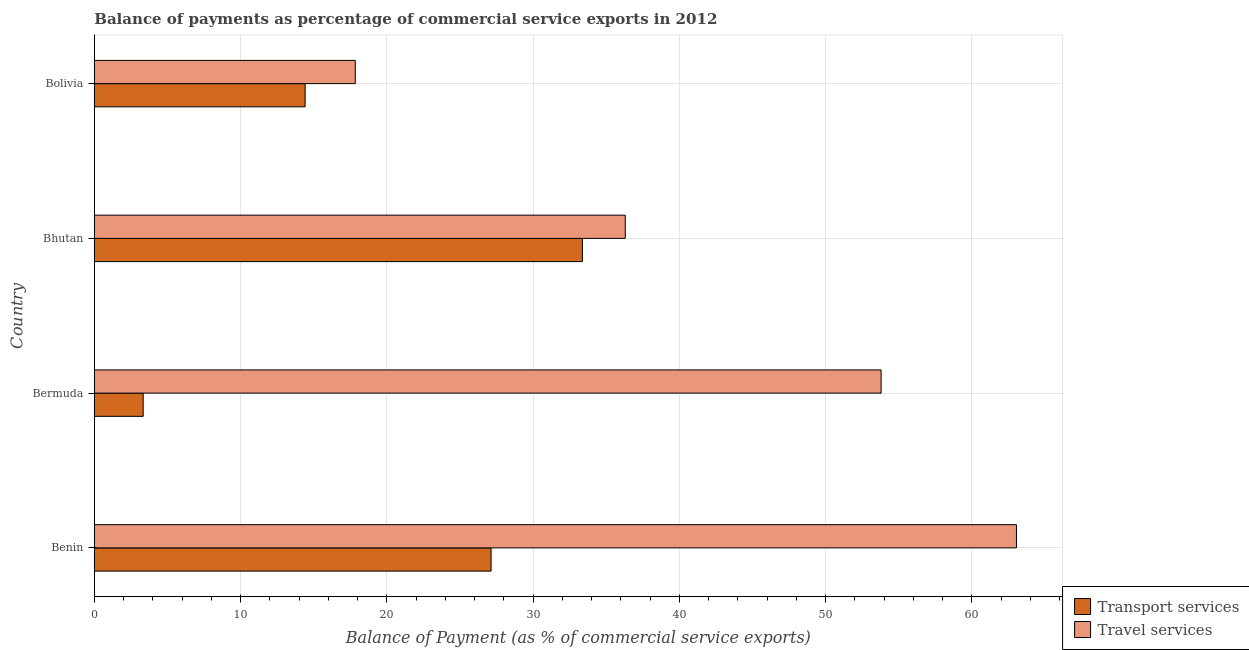How many different coloured bars are there?
Provide a short and direct response. 2. Are the number of bars per tick equal to the number of legend labels?
Make the answer very short. Yes. How many bars are there on the 3rd tick from the top?
Your answer should be very brief. 2. How many bars are there on the 2nd tick from the bottom?
Provide a short and direct response. 2. In how many cases, is the number of bars for a given country not equal to the number of legend labels?
Make the answer very short. 0. What is the balance of payments of transport services in Bolivia?
Provide a succinct answer. 14.41. Across all countries, what is the maximum balance of payments of transport services?
Ensure brevity in your answer.  33.37. Across all countries, what is the minimum balance of payments of transport services?
Your response must be concise. 3.34. In which country was the balance of payments of transport services maximum?
Provide a short and direct response. Bhutan. In which country was the balance of payments of transport services minimum?
Keep it short and to the point. Bermuda. What is the total balance of payments of transport services in the graph?
Offer a terse response. 78.25. What is the difference between the balance of payments of transport services in Bermuda and that in Bolivia?
Offer a terse response. -11.07. What is the difference between the balance of payments of travel services in Bhutan and the balance of payments of transport services in Bolivia?
Provide a short and direct response. 21.89. What is the average balance of payments of travel services per country?
Give a very brief answer. 42.75. What is the difference between the balance of payments of transport services and balance of payments of travel services in Bermuda?
Offer a terse response. -50.46. What is the ratio of the balance of payments of travel services in Benin to that in Bolivia?
Ensure brevity in your answer.  3.53. Is the difference between the balance of payments of travel services in Bhutan and Bolivia greater than the difference between the balance of payments of transport services in Bhutan and Bolivia?
Give a very brief answer. No. What is the difference between the highest and the second highest balance of payments of transport services?
Ensure brevity in your answer.  6.24. What is the difference between the highest and the lowest balance of payments of travel services?
Your answer should be very brief. 45.21. In how many countries, is the balance of payments of travel services greater than the average balance of payments of travel services taken over all countries?
Give a very brief answer. 2. What does the 2nd bar from the top in Bhutan represents?
Give a very brief answer. Transport services. What does the 2nd bar from the bottom in Bhutan represents?
Your response must be concise. Travel services. Are all the bars in the graph horizontal?
Your response must be concise. Yes. How many countries are there in the graph?
Your answer should be compact. 4. Are the values on the major ticks of X-axis written in scientific E-notation?
Provide a succinct answer. No. Does the graph contain any zero values?
Offer a very short reply. No. Does the graph contain grids?
Ensure brevity in your answer.  Yes. Where does the legend appear in the graph?
Offer a terse response. Bottom right. How are the legend labels stacked?
Make the answer very short. Vertical. What is the title of the graph?
Your response must be concise. Balance of payments as percentage of commercial service exports in 2012. What is the label or title of the X-axis?
Offer a very short reply. Balance of Payment (as % of commercial service exports). What is the Balance of Payment (as % of commercial service exports) of Transport services in Benin?
Keep it short and to the point. 27.13. What is the Balance of Payment (as % of commercial service exports) in Travel services in Benin?
Provide a short and direct response. 63.05. What is the Balance of Payment (as % of commercial service exports) in Transport services in Bermuda?
Offer a very short reply. 3.34. What is the Balance of Payment (as % of commercial service exports) in Travel services in Bermuda?
Your response must be concise. 53.8. What is the Balance of Payment (as % of commercial service exports) in Transport services in Bhutan?
Keep it short and to the point. 33.37. What is the Balance of Payment (as % of commercial service exports) of Travel services in Bhutan?
Provide a succinct answer. 36.3. What is the Balance of Payment (as % of commercial service exports) of Transport services in Bolivia?
Offer a very short reply. 14.41. What is the Balance of Payment (as % of commercial service exports) of Travel services in Bolivia?
Your answer should be very brief. 17.84. Across all countries, what is the maximum Balance of Payment (as % of commercial service exports) of Transport services?
Your answer should be compact. 33.37. Across all countries, what is the maximum Balance of Payment (as % of commercial service exports) in Travel services?
Offer a terse response. 63.05. Across all countries, what is the minimum Balance of Payment (as % of commercial service exports) in Transport services?
Make the answer very short. 3.34. Across all countries, what is the minimum Balance of Payment (as % of commercial service exports) in Travel services?
Provide a succinct answer. 17.84. What is the total Balance of Payment (as % of commercial service exports) of Transport services in the graph?
Your answer should be compact. 78.25. What is the total Balance of Payment (as % of commercial service exports) in Travel services in the graph?
Your answer should be compact. 171. What is the difference between the Balance of Payment (as % of commercial service exports) in Transport services in Benin and that in Bermuda?
Give a very brief answer. 23.79. What is the difference between the Balance of Payment (as % of commercial service exports) of Travel services in Benin and that in Bermuda?
Offer a very short reply. 9.25. What is the difference between the Balance of Payment (as % of commercial service exports) of Transport services in Benin and that in Bhutan?
Your answer should be compact. -6.24. What is the difference between the Balance of Payment (as % of commercial service exports) of Travel services in Benin and that in Bhutan?
Provide a short and direct response. 26.75. What is the difference between the Balance of Payment (as % of commercial service exports) in Transport services in Benin and that in Bolivia?
Your response must be concise. 12.72. What is the difference between the Balance of Payment (as % of commercial service exports) in Travel services in Benin and that in Bolivia?
Offer a terse response. 45.21. What is the difference between the Balance of Payment (as % of commercial service exports) of Transport services in Bermuda and that in Bhutan?
Provide a succinct answer. -30.03. What is the difference between the Balance of Payment (as % of commercial service exports) of Travel services in Bermuda and that in Bhutan?
Provide a short and direct response. 17.5. What is the difference between the Balance of Payment (as % of commercial service exports) in Transport services in Bermuda and that in Bolivia?
Provide a succinct answer. -11.07. What is the difference between the Balance of Payment (as % of commercial service exports) of Travel services in Bermuda and that in Bolivia?
Ensure brevity in your answer.  35.96. What is the difference between the Balance of Payment (as % of commercial service exports) in Transport services in Bhutan and that in Bolivia?
Offer a terse response. 18.96. What is the difference between the Balance of Payment (as % of commercial service exports) in Travel services in Bhutan and that in Bolivia?
Keep it short and to the point. 18.46. What is the difference between the Balance of Payment (as % of commercial service exports) in Transport services in Benin and the Balance of Payment (as % of commercial service exports) in Travel services in Bermuda?
Provide a short and direct response. -26.67. What is the difference between the Balance of Payment (as % of commercial service exports) in Transport services in Benin and the Balance of Payment (as % of commercial service exports) in Travel services in Bhutan?
Provide a short and direct response. -9.18. What is the difference between the Balance of Payment (as % of commercial service exports) of Transport services in Benin and the Balance of Payment (as % of commercial service exports) of Travel services in Bolivia?
Offer a terse response. 9.29. What is the difference between the Balance of Payment (as % of commercial service exports) in Transport services in Bermuda and the Balance of Payment (as % of commercial service exports) in Travel services in Bhutan?
Offer a terse response. -32.97. What is the difference between the Balance of Payment (as % of commercial service exports) in Transport services in Bermuda and the Balance of Payment (as % of commercial service exports) in Travel services in Bolivia?
Give a very brief answer. -14.51. What is the difference between the Balance of Payment (as % of commercial service exports) in Transport services in Bhutan and the Balance of Payment (as % of commercial service exports) in Travel services in Bolivia?
Keep it short and to the point. 15.53. What is the average Balance of Payment (as % of commercial service exports) in Transport services per country?
Make the answer very short. 19.56. What is the average Balance of Payment (as % of commercial service exports) of Travel services per country?
Offer a terse response. 42.75. What is the difference between the Balance of Payment (as % of commercial service exports) of Transport services and Balance of Payment (as % of commercial service exports) of Travel services in Benin?
Your response must be concise. -35.92. What is the difference between the Balance of Payment (as % of commercial service exports) in Transport services and Balance of Payment (as % of commercial service exports) in Travel services in Bermuda?
Give a very brief answer. -50.46. What is the difference between the Balance of Payment (as % of commercial service exports) in Transport services and Balance of Payment (as % of commercial service exports) in Travel services in Bhutan?
Keep it short and to the point. -2.93. What is the difference between the Balance of Payment (as % of commercial service exports) of Transport services and Balance of Payment (as % of commercial service exports) of Travel services in Bolivia?
Give a very brief answer. -3.43. What is the ratio of the Balance of Payment (as % of commercial service exports) in Transport services in Benin to that in Bermuda?
Your response must be concise. 8.12. What is the ratio of the Balance of Payment (as % of commercial service exports) in Travel services in Benin to that in Bermuda?
Provide a short and direct response. 1.17. What is the ratio of the Balance of Payment (as % of commercial service exports) of Transport services in Benin to that in Bhutan?
Make the answer very short. 0.81. What is the ratio of the Balance of Payment (as % of commercial service exports) in Travel services in Benin to that in Bhutan?
Your answer should be compact. 1.74. What is the ratio of the Balance of Payment (as % of commercial service exports) in Transport services in Benin to that in Bolivia?
Provide a succinct answer. 1.88. What is the ratio of the Balance of Payment (as % of commercial service exports) of Travel services in Benin to that in Bolivia?
Your answer should be compact. 3.53. What is the ratio of the Balance of Payment (as % of commercial service exports) in Transport services in Bermuda to that in Bhutan?
Make the answer very short. 0.1. What is the ratio of the Balance of Payment (as % of commercial service exports) of Travel services in Bermuda to that in Bhutan?
Ensure brevity in your answer.  1.48. What is the ratio of the Balance of Payment (as % of commercial service exports) in Transport services in Bermuda to that in Bolivia?
Keep it short and to the point. 0.23. What is the ratio of the Balance of Payment (as % of commercial service exports) in Travel services in Bermuda to that in Bolivia?
Keep it short and to the point. 3.02. What is the ratio of the Balance of Payment (as % of commercial service exports) in Transport services in Bhutan to that in Bolivia?
Provide a succinct answer. 2.32. What is the ratio of the Balance of Payment (as % of commercial service exports) of Travel services in Bhutan to that in Bolivia?
Provide a short and direct response. 2.03. What is the difference between the highest and the second highest Balance of Payment (as % of commercial service exports) in Transport services?
Your answer should be very brief. 6.24. What is the difference between the highest and the second highest Balance of Payment (as % of commercial service exports) of Travel services?
Make the answer very short. 9.25. What is the difference between the highest and the lowest Balance of Payment (as % of commercial service exports) in Transport services?
Give a very brief answer. 30.03. What is the difference between the highest and the lowest Balance of Payment (as % of commercial service exports) of Travel services?
Keep it short and to the point. 45.21. 